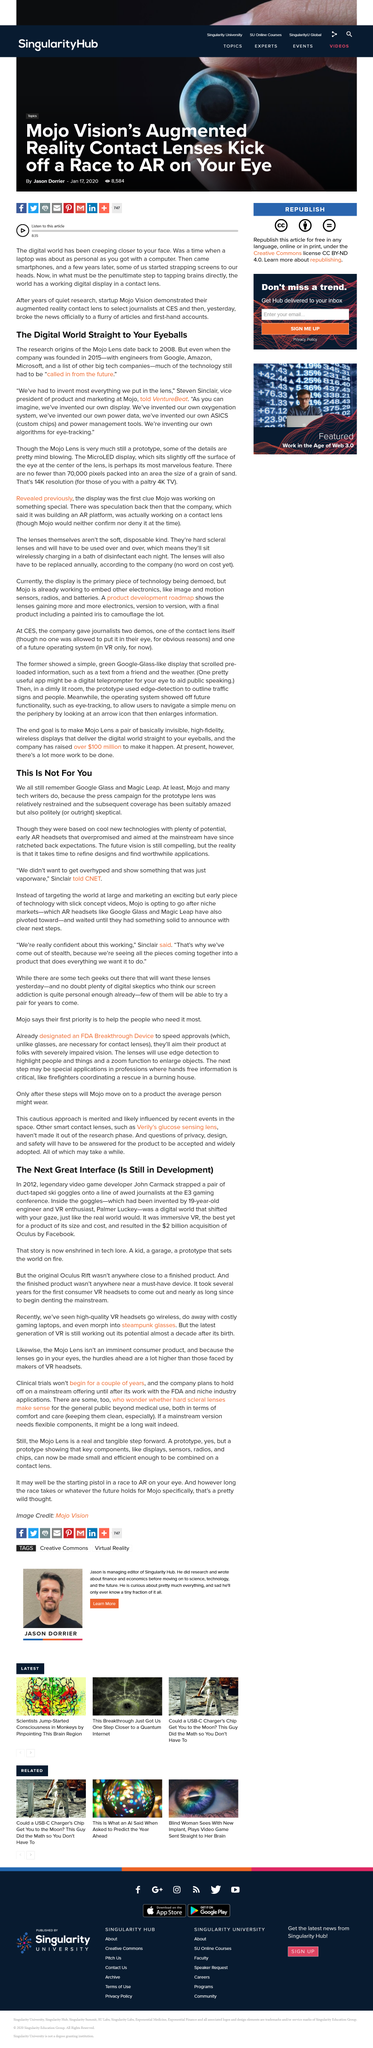Highlight a few significant elements in this photo. Magic Leap and Google Glass are both examples of augmented reality (AR) headsets. John Carmack is a legendary video game developer who has made significant contributions to the gaming industry. The Mojo Lens is a device that transmits information directly to the wearer's eyes, allowing for an enhanced and convenient experience of receiving and processing information. I am a tech writer who still remember Google Glass and Magic Leap, they are known as Mojo. Google Glass and Magic Leap were designed for the mainstream. 